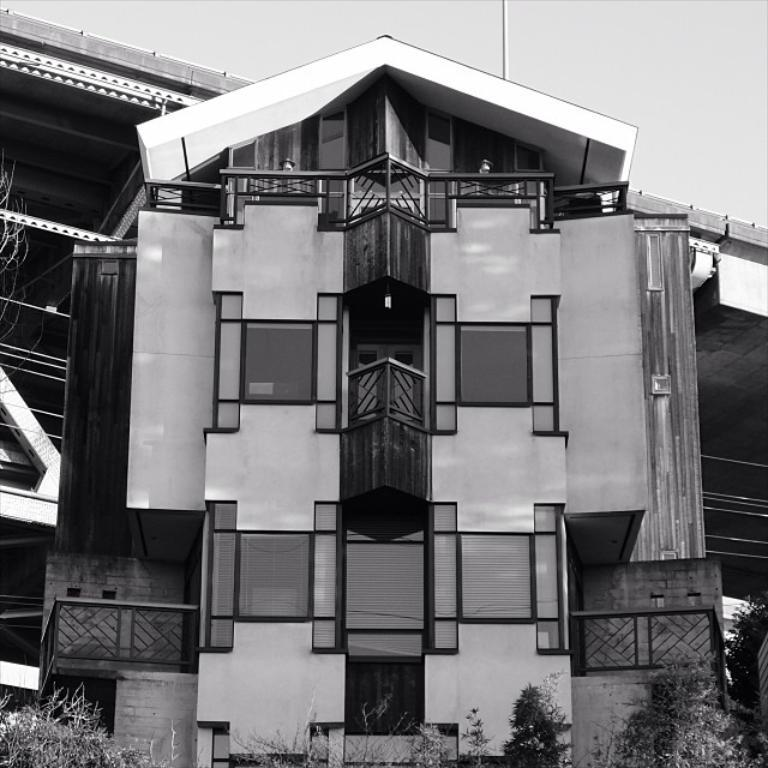What is the color scheme of the image? The image is black and white. What can be seen in the background of the image? There are trees, buildings, and the sky visible in the background of the image. How many beetles can be seen in the image? There are no beetles present in the image. What type of pets are visible in the image? There are no pets visible in the image. 